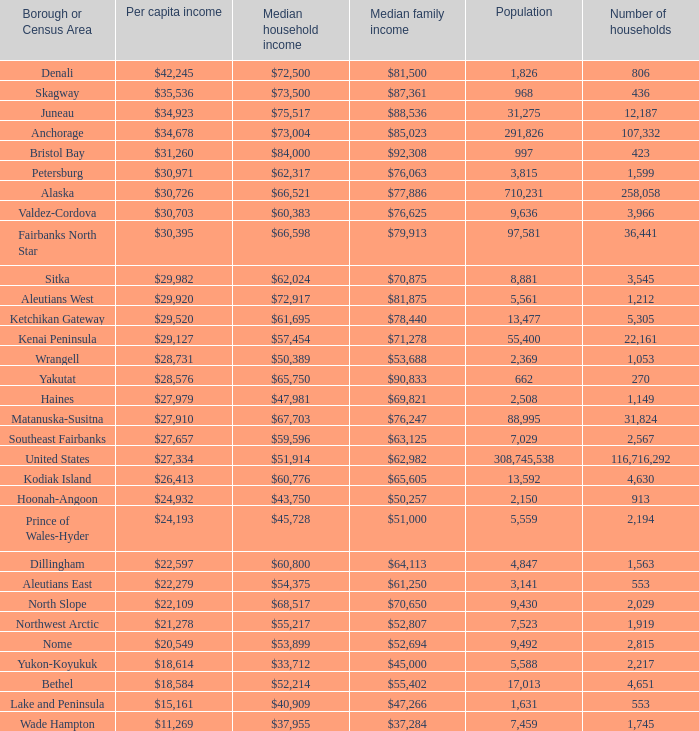What is the population of the area with a median family income of $71,278? 1.0. 